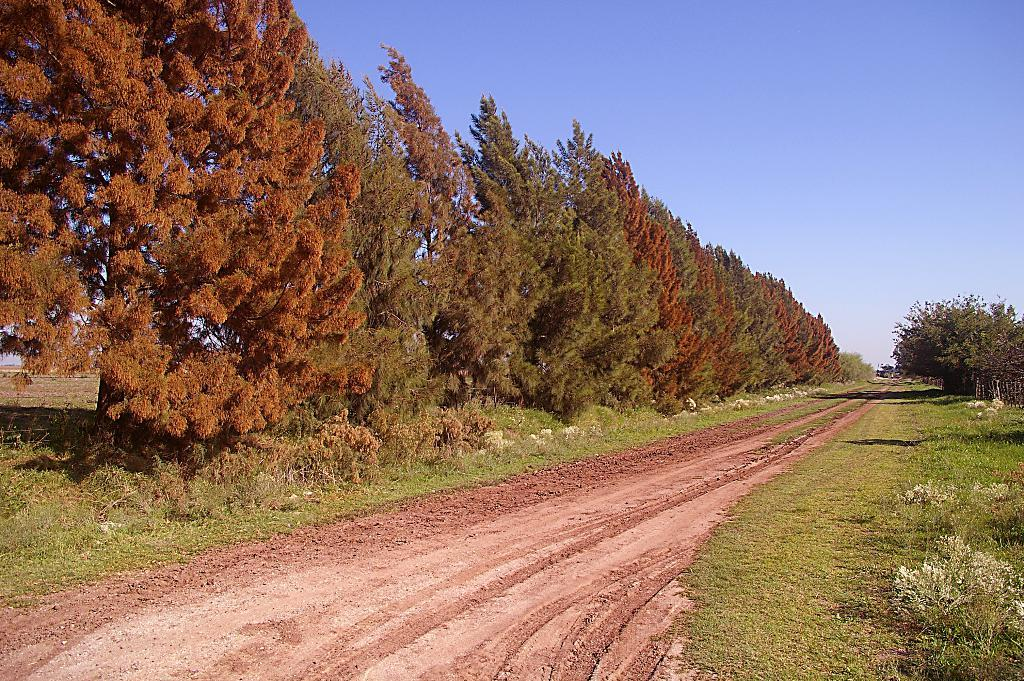What type of vegetation is present in the image? There are trees with branches and leaves in the image, as well as small plants. Can you describe the road in the image? There appears to be a road in the image, but its specific characteristics are not mentioned in the provided facts. What is the size of the plants in the image? The provided facts do not mention the size of the plants in the image. What type of underwear can be seen hanging on the trees in the image? There is no underwear present in the image; it features trees with branches and leaves, and small plants. 